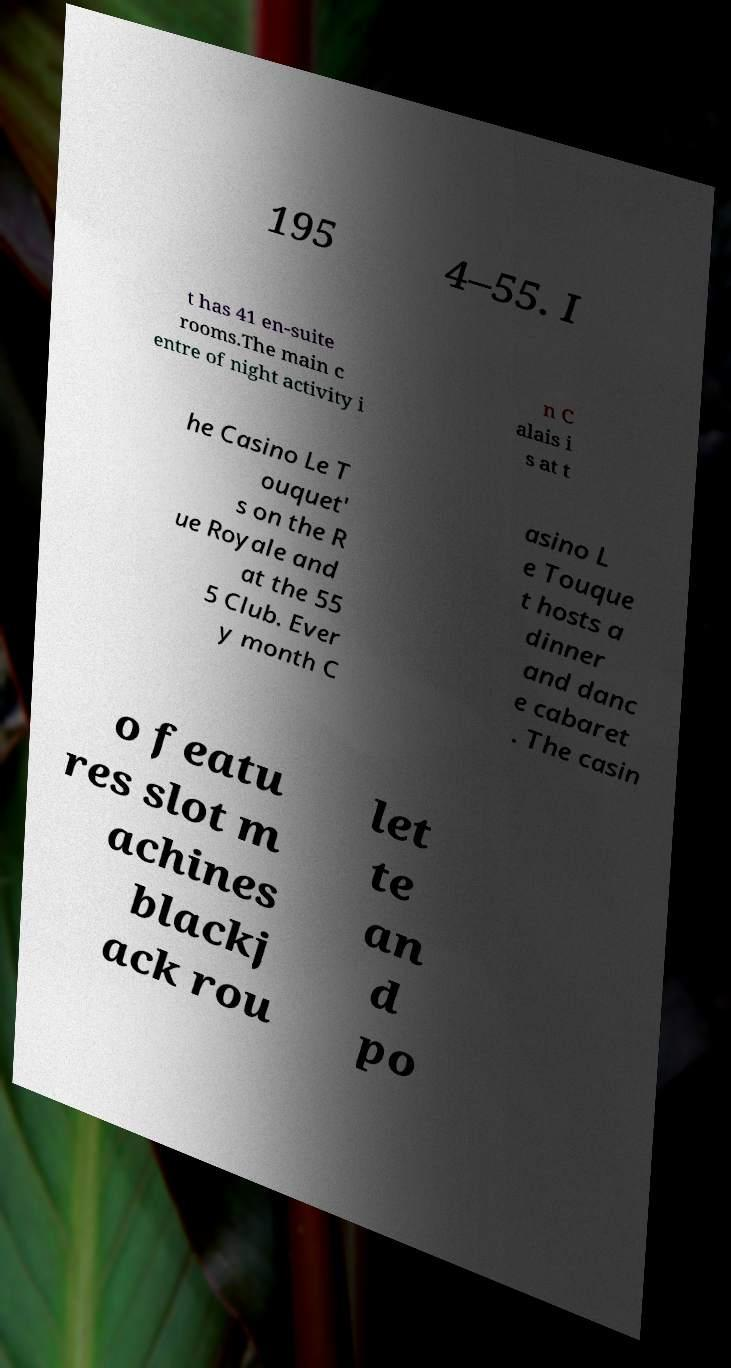Please read and relay the text visible in this image. What does it say? 195 4–55. I t has 41 en-suite rooms.The main c entre of night activity i n C alais i s at t he Casino Le T ouquet' s on the R ue Royale and at the 55 5 Club. Ever y month C asino L e Touque t hosts a dinner and danc e cabaret . The casin o featu res slot m achines blackj ack rou let te an d po 